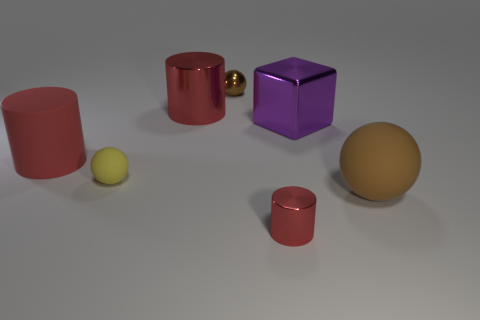What is the material of the other big cylinder that is the same color as the big rubber cylinder?
Keep it short and to the point. Metal. There is a brown metal object that is the same shape as the tiny yellow matte object; what size is it?
Keep it short and to the point. Small. Is there any other thing that has the same size as the yellow ball?
Keep it short and to the point. Yes. How many things are cylinders behind the small metallic cylinder or red cylinders right of the big red shiny cylinder?
Your response must be concise. 3. Is the brown shiny object the same size as the yellow matte thing?
Your answer should be compact. Yes. Are there more large blue cylinders than brown spheres?
Your answer should be compact. No. What number of other objects are there of the same color as the big metal cylinder?
Your response must be concise. 2. How many things are either matte cylinders or yellow rubber things?
Provide a succinct answer. 2. There is a small metallic object to the left of the small red object; is it the same shape as the large purple metallic object?
Give a very brief answer. No. What is the color of the shiny object to the right of the shiny cylinder right of the tiny brown metal object?
Offer a very short reply. Purple. 